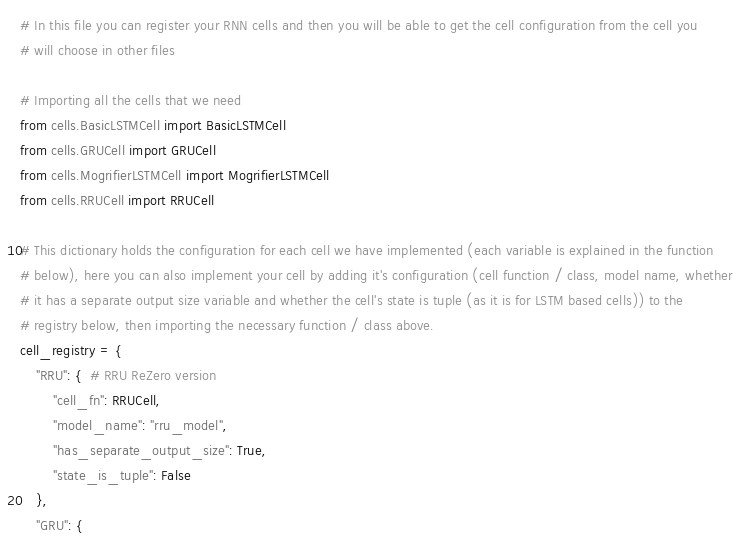Convert code to text. <code><loc_0><loc_0><loc_500><loc_500><_Python_># In this file you can register your RNN cells and then you will be able to get the cell configuration from the cell you
# will choose in other files

# Importing all the cells that we need
from cells.BasicLSTMCell import BasicLSTMCell
from cells.GRUCell import GRUCell
from cells.MogrifierLSTMCell import MogrifierLSTMCell
from cells.RRUCell import RRUCell

# This dictionary holds the configuration for each cell we have implemented (each variable is explained in the function
# below), here you can also implement your cell by adding it's configuration (cell function / class, model name, whether
# it has a separate output size variable and whether the cell's state is tuple (as it is for LSTM based cells)) to the
# registry below, then importing the necessary function / class above.
cell_registry = {
    "RRU": {  # RRU ReZero version
        "cell_fn": RRUCell,
        "model_name": "rru_model",
        "has_separate_output_size": True,
        "state_is_tuple": False
    },
    "GRU": {</code> 